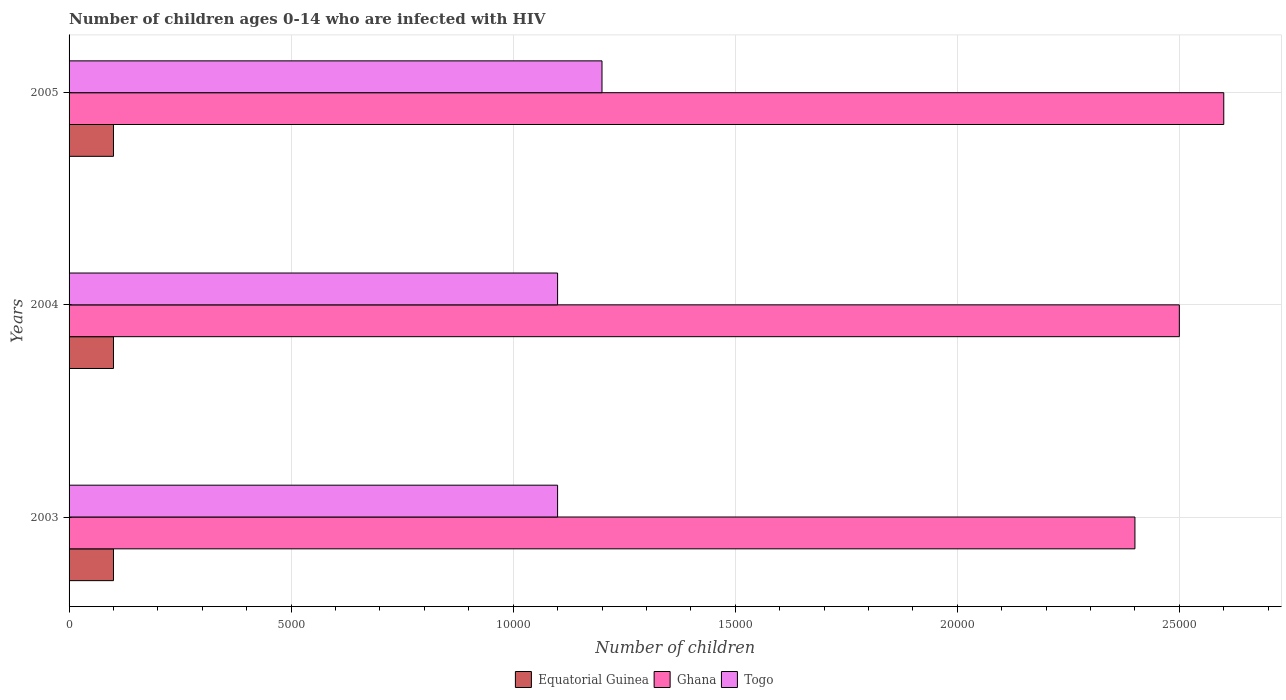Are the number of bars per tick equal to the number of legend labels?
Your response must be concise. Yes. Are the number of bars on each tick of the Y-axis equal?
Your answer should be compact. Yes. In how many cases, is the number of bars for a given year not equal to the number of legend labels?
Ensure brevity in your answer.  0. What is the number of HIV infected children in Togo in 2005?
Your answer should be compact. 1.20e+04. Across all years, what is the maximum number of HIV infected children in Togo?
Offer a terse response. 1.20e+04. Across all years, what is the minimum number of HIV infected children in Togo?
Ensure brevity in your answer.  1.10e+04. In which year was the number of HIV infected children in Togo maximum?
Your answer should be compact. 2005. In which year was the number of HIV infected children in Ghana minimum?
Offer a terse response. 2003. What is the total number of HIV infected children in Equatorial Guinea in the graph?
Your answer should be compact. 3000. What is the difference between the number of HIV infected children in Togo in 2003 and that in 2004?
Provide a succinct answer. 0. What is the difference between the number of HIV infected children in Ghana in 2004 and the number of HIV infected children in Equatorial Guinea in 2005?
Provide a short and direct response. 2.40e+04. What is the average number of HIV infected children in Ghana per year?
Give a very brief answer. 2.50e+04. In the year 2004, what is the difference between the number of HIV infected children in Ghana and number of HIV infected children in Equatorial Guinea?
Provide a succinct answer. 2.40e+04. In how many years, is the number of HIV infected children in Ghana greater than 2000 ?
Your answer should be compact. 3. Is the difference between the number of HIV infected children in Ghana in 2003 and 2005 greater than the difference between the number of HIV infected children in Equatorial Guinea in 2003 and 2005?
Provide a short and direct response. No. What is the difference between the highest and the lowest number of HIV infected children in Togo?
Your response must be concise. 1000. Is the sum of the number of HIV infected children in Ghana in 2003 and 2005 greater than the maximum number of HIV infected children in Equatorial Guinea across all years?
Give a very brief answer. Yes. What does the 1st bar from the top in 2004 represents?
Give a very brief answer. Togo. What does the 1st bar from the bottom in 2003 represents?
Make the answer very short. Equatorial Guinea. How many bars are there?
Provide a succinct answer. 9. How many years are there in the graph?
Ensure brevity in your answer.  3. Are the values on the major ticks of X-axis written in scientific E-notation?
Your answer should be very brief. No. Does the graph contain any zero values?
Provide a short and direct response. No. Where does the legend appear in the graph?
Ensure brevity in your answer.  Bottom center. How are the legend labels stacked?
Provide a succinct answer. Horizontal. What is the title of the graph?
Keep it short and to the point. Number of children ages 0-14 who are infected with HIV. Does "Oman" appear as one of the legend labels in the graph?
Make the answer very short. No. What is the label or title of the X-axis?
Your response must be concise. Number of children. What is the Number of children of Equatorial Guinea in 2003?
Provide a succinct answer. 1000. What is the Number of children in Ghana in 2003?
Give a very brief answer. 2.40e+04. What is the Number of children of Togo in 2003?
Provide a short and direct response. 1.10e+04. What is the Number of children in Ghana in 2004?
Make the answer very short. 2.50e+04. What is the Number of children of Togo in 2004?
Your answer should be very brief. 1.10e+04. What is the Number of children of Ghana in 2005?
Ensure brevity in your answer.  2.60e+04. What is the Number of children of Togo in 2005?
Your response must be concise. 1.20e+04. Across all years, what is the maximum Number of children in Equatorial Guinea?
Offer a terse response. 1000. Across all years, what is the maximum Number of children of Ghana?
Provide a succinct answer. 2.60e+04. Across all years, what is the maximum Number of children in Togo?
Make the answer very short. 1.20e+04. Across all years, what is the minimum Number of children in Equatorial Guinea?
Your answer should be very brief. 1000. Across all years, what is the minimum Number of children of Ghana?
Keep it short and to the point. 2.40e+04. Across all years, what is the minimum Number of children of Togo?
Give a very brief answer. 1.10e+04. What is the total Number of children in Equatorial Guinea in the graph?
Make the answer very short. 3000. What is the total Number of children in Ghana in the graph?
Provide a short and direct response. 7.50e+04. What is the total Number of children in Togo in the graph?
Make the answer very short. 3.40e+04. What is the difference between the Number of children in Ghana in 2003 and that in 2004?
Your answer should be compact. -1000. What is the difference between the Number of children of Equatorial Guinea in 2003 and that in 2005?
Offer a terse response. 0. What is the difference between the Number of children in Ghana in 2003 and that in 2005?
Offer a terse response. -2000. What is the difference between the Number of children in Togo in 2003 and that in 2005?
Make the answer very short. -1000. What is the difference between the Number of children of Equatorial Guinea in 2004 and that in 2005?
Give a very brief answer. 0. What is the difference between the Number of children in Ghana in 2004 and that in 2005?
Keep it short and to the point. -1000. What is the difference between the Number of children in Togo in 2004 and that in 2005?
Give a very brief answer. -1000. What is the difference between the Number of children of Equatorial Guinea in 2003 and the Number of children of Ghana in 2004?
Your response must be concise. -2.40e+04. What is the difference between the Number of children in Equatorial Guinea in 2003 and the Number of children in Togo in 2004?
Ensure brevity in your answer.  -10000. What is the difference between the Number of children of Ghana in 2003 and the Number of children of Togo in 2004?
Your response must be concise. 1.30e+04. What is the difference between the Number of children in Equatorial Guinea in 2003 and the Number of children in Ghana in 2005?
Offer a very short reply. -2.50e+04. What is the difference between the Number of children of Equatorial Guinea in 2003 and the Number of children of Togo in 2005?
Your answer should be very brief. -1.10e+04. What is the difference between the Number of children in Ghana in 2003 and the Number of children in Togo in 2005?
Your answer should be very brief. 1.20e+04. What is the difference between the Number of children in Equatorial Guinea in 2004 and the Number of children in Ghana in 2005?
Your answer should be compact. -2.50e+04. What is the difference between the Number of children of Equatorial Guinea in 2004 and the Number of children of Togo in 2005?
Your response must be concise. -1.10e+04. What is the difference between the Number of children in Ghana in 2004 and the Number of children in Togo in 2005?
Provide a succinct answer. 1.30e+04. What is the average Number of children of Ghana per year?
Offer a terse response. 2.50e+04. What is the average Number of children in Togo per year?
Provide a succinct answer. 1.13e+04. In the year 2003, what is the difference between the Number of children of Equatorial Guinea and Number of children of Ghana?
Your answer should be compact. -2.30e+04. In the year 2003, what is the difference between the Number of children in Equatorial Guinea and Number of children in Togo?
Offer a terse response. -10000. In the year 2003, what is the difference between the Number of children of Ghana and Number of children of Togo?
Keep it short and to the point. 1.30e+04. In the year 2004, what is the difference between the Number of children of Equatorial Guinea and Number of children of Ghana?
Your answer should be very brief. -2.40e+04. In the year 2004, what is the difference between the Number of children in Ghana and Number of children in Togo?
Offer a very short reply. 1.40e+04. In the year 2005, what is the difference between the Number of children of Equatorial Guinea and Number of children of Ghana?
Your answer should be very brief. -2.50e+04. In the year 2005, what is the difference between the Number of children in Equatorial Guinea and Number of children in Togo?
Provide a succinct answer. -1.10e+04. In the year 2005, what is the difference between the Number of children in Ghana and Number of children in Togo?
Give a very brief answer. 1.40e+04. What is the ratio of the Number of children in Equatorial Guinea in 2003 to that in 2004?
Give a very brief answer. 1. What is the ratio of the Number of children in Ghana in 2003 to that in 2004?
Make the answer very short. 0.96. What is the ratio of the Number of children in Equatorial Guinea in 2003 to that in 2005?
Provide a short and direct response. 1. What is the ratio of the Number of children in Equatorial Guinea in 2004 to that in 2005?
Offer a terse response. 1. What is the ratio of the Number of children in Ghana in 2004 to that in 2005?
Provide a short and direct response. 0.96. What is the difference between the highest and the second highest Number of children in Equatorial Guinea?
Your answer should be very brief. 0. What is the difference between the highest and the second highest Number of children of Ghana?
Your answer should be very brief. 1000. What is the difference between the highest and the second highest Number of children of Togo?
Provide a short and direct response. 1000. What is the difference between the highest and the lowest Number of children of Equatorial Guinea?
Your answer should be compact. 0. What is the difference between the highest and the lowest Number of children in Ghana?
Keep it short and to the point. 2000. What is the difference between the highest and the lowest Number of children of Togo?
Your answer should be very brief. 1000. 